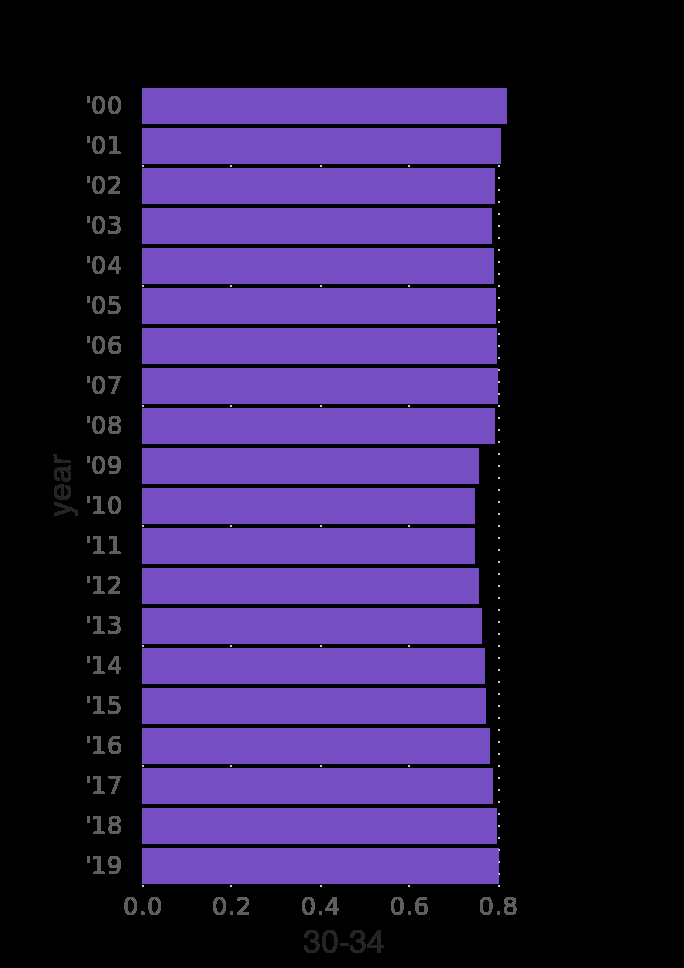<image>
What does the bar diagram show for the 30-34 age group?  The bar diagram shows the employment rate for the 30-34 age group in the United States from 2000 to 2019. What is the purpose of the categorical scale on the y-axis? The categorical scale on the y-axis is used to mark the years from 2000 to 2019. please summary the statistics and relations of the chart Employment rate in the United States shows that it is 0.8 or very close to 0.8 between 2000 and 2019. What is labeled on the x-axis of the diagram?  The x-axis of the diagram is labeled with the age group "30-34". 